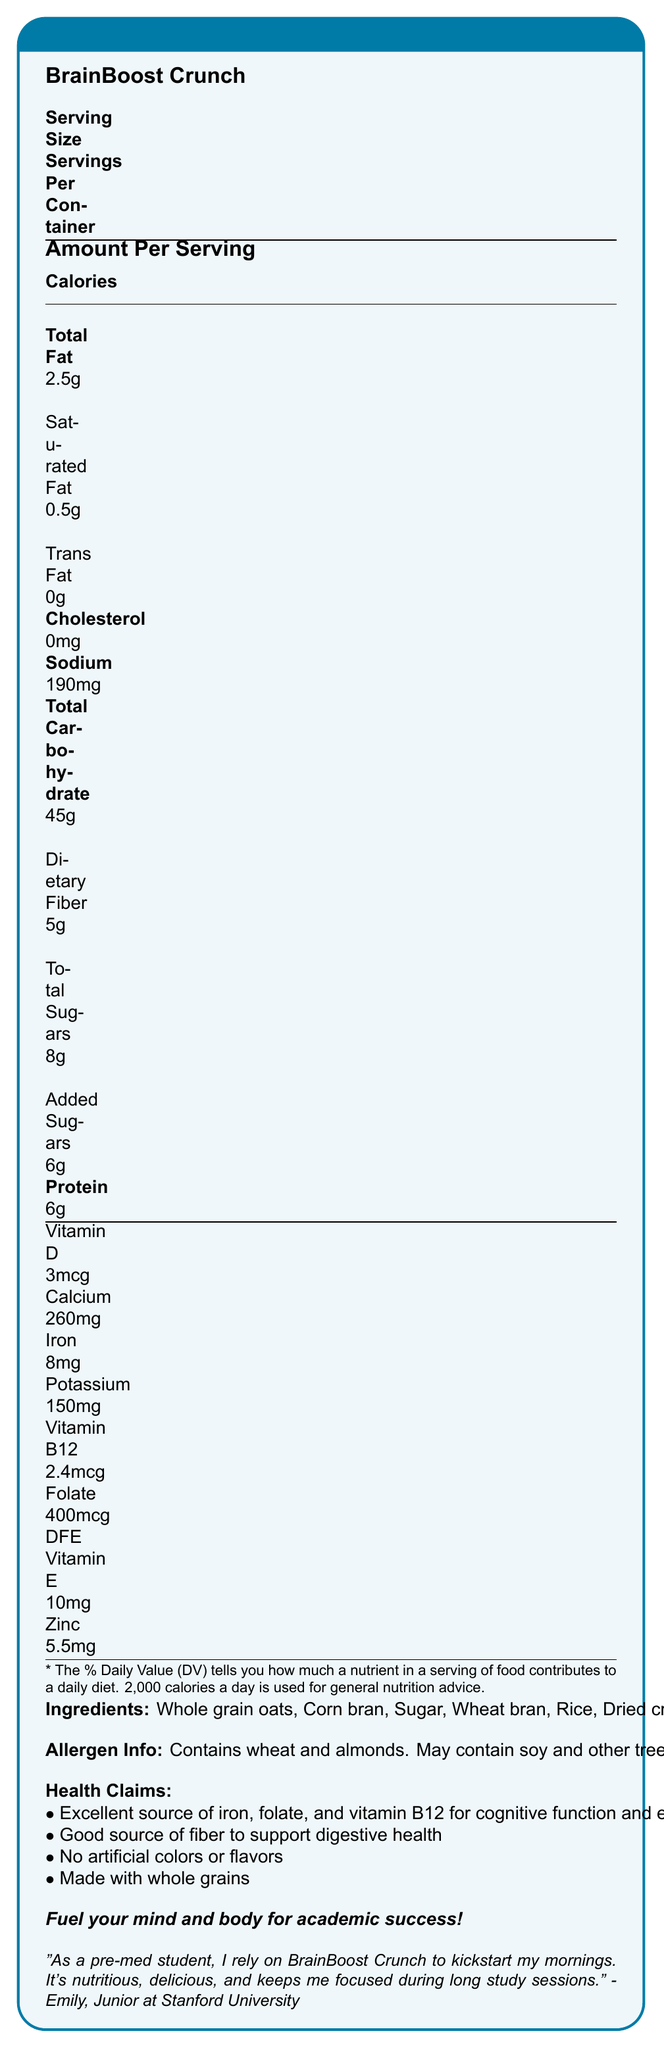what is the serving size of BrainBoost Crunch? The document clearly states the serving size as 1 cup (55g).
Answer: 1 cup (55g) what is the serving per container? The servings per container is listed as "About 8" in the document.
Answer: About 8 how many calories are there per serving? The calorie count per serving is mentioned as 210 calories.
Answer: 210 what percentage of the daily value of iron does one serving contain? One serving contains 45% of the daily value of iron, according to the document.
Answer: 45% what is the total carbohydrate content in a serving? The document lists the total carbohydrate content per serving as 45g.
Answer: 45g is BrainBoost Crunch free of artificial colors or flavors? The document mentions that the product has "No artificial colors or flavors."
Answer: Yes how much dietary fiber is in each serving of BrainBoost Crunch? The dietary fiber content per serving is listed as 5g.
Answer: 5g how much added sugars does each serving contain? The added sugars in each serving are 6g according to the nutrition facts.
Answer: 6g which of the following vitamins has a 100% daily value in BrainBoost Crunch? A. Vitamin D B. Vitamin B12 C. Vitamin E D. Vitamin C The document shows that Vitamin B12 has a 100% daily value in each serving.
Answer: B which allergenic ingredients are contained in BrainBoost Crunch? A. Wheat and soy B. Almonds and peanuts C. Wheat and almonds D. Soy and rice The allergen info states that BrainBoost Crunch contains wheat and almonds.
Answer: C does BrainBoost Crunch contain cholesterol? The nutrition facts indicate that the cereal has 0mg of cholesterol.
Answer: No summarize the main idea of the document. The document details the nutritional content, ingredients, and health claims of BrainBoost Crunch, emphasizing its benefits for mental and physical performance without artificial additives.
Answer: BrainBoost Crunch is a vitamin-fortified breakfast cereal designed for health-conscious college students. It provides significant nutrients like iron, folate, and vitamin B12, supports cognitive function and digestive health, and is free from artificial colors and flavors. what is the recommended daily calorie intake used for general nutrition advice according to the document? The footnote in the document states that 2,000 calories a day is used for general nutrition advice.
Answer: 2,000 calories who provided the testimonial for BrainBoost Crunch? The testimonial is from Emily, a junior at Stanford University.
Answer: Emily, Junior at Stanford University how much folate is there in one serving of BrainBoost Crunch? The document lists the folate content as 400mcg DFE per serving.
Answer: 400mcg DFE can BrainBoost Crunch help improve cognitive function and energy metabolism? The health claims state that it’s an excellent source of iron, folate, and vitamin B12, which support cognitive function and energy metabolism.
Answer: Yes what is the total fat content in a single serving of BrainBoost Crunch? A. 0.5g B. 2g C. 2.5g D. 3g The document lists the total fat content as 2.5g per serving.
Answer: C how many types of bran are listed as ingredients in BrainBoost Crunch? The ingredients list includes whole grain oats and corn bran.
Answer: 2 does BrainBoost Crunch contain any trans fat? The document clearly states the trans fat content as 0g.
Answer: No what is the tagline used in the marketing of BrainBoost Crunch? The marketing tagline is mentioned at the end of the nutrition facts box.
Answer: "Fuel your mind and body for academic success!" is the amount of vitamin C in BrainBoost Crunch listed in the document? The document does not include details on the amount of vitamin C.
Answer: Not enough information 